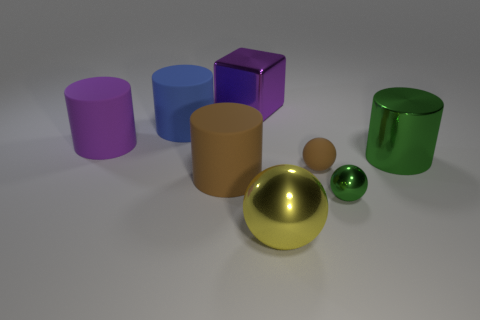What materials do these objects seem to be made of? The objects appear to have a smooth, reflective surface, suggesting they are made of materials like polished metal or plastic with a high-gloss finish. 